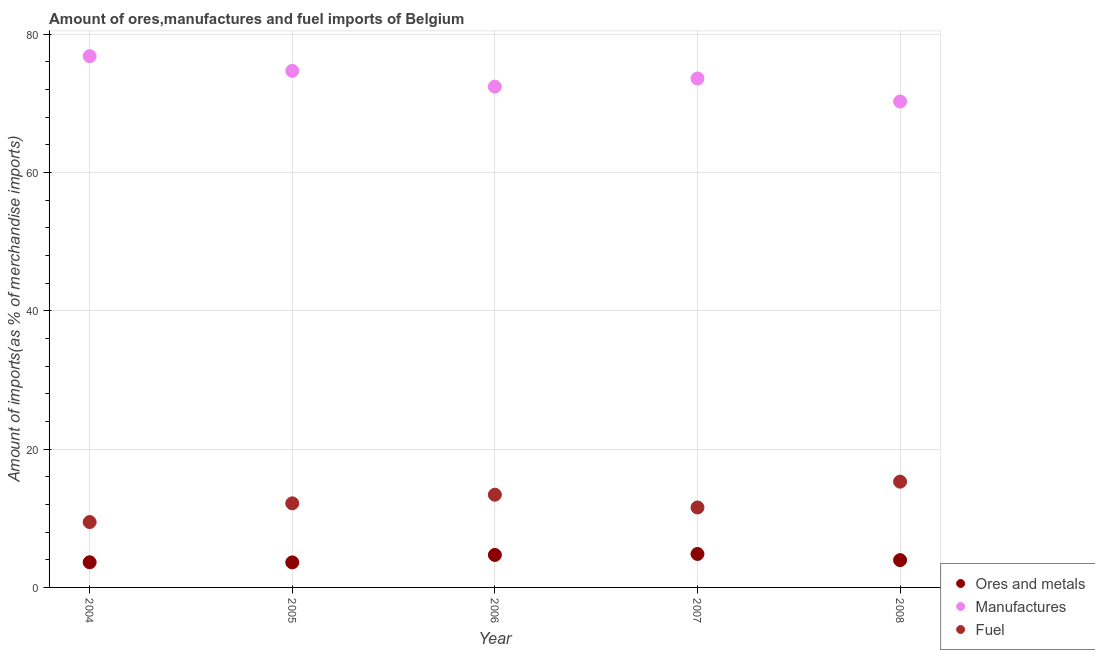How many different coloured dotlines are there?
Your response must be concise. 3. Is the number of dotlines equal to the number of legend labels?
Ensure brevity in your answer.  Yes. What is the percentage of fuel imports in 2004?
Keep it short and to the point. 9.45. Across all years, what is the maximum percentage of manufactures imports?
Give a very brief answer. 76.8. Across all years, what is the minimum percentage of ores and metals imports?
Keep it short and to the point. 3.62. In which year was the percentage of manufactures imports maximum?
Make the answer very short. 2004. In which year was the percentage of fuel imports minimum?
Give a very brief answer. 2004. What is the total percentage of ores and metals imports in the graph?
Offer a very short reply. 20.73. What is the difference between the percentage of manufactures imports in 2005 and that in 2008?
Give a very brief answer. 4.43. What is the difference between the percentage of ores and metals imports in 2007 and the percentage of manufactures imports in 2008?
Keep it short and to the point. -65.41. What is the average percentage of ores and metals imports per year?
Provide a short and direct response. 4.15. In the year 2004, what is the difference between the percentage of ores and metals imports and percentage of fuel imports?
Provide a short and direct response. -5.81. What is the ratio of the percentage of fuel imports in 2005 to that in 2006?
Keep it short and to the point. 0.91. Is the percentage of ores and metals imports in 2004 less than that in 2008?
Give a very brief answer. Yes. What is the difference between the highest and the second highest percentage of fuel imports?
Offer a terse response. 1.88. What is the difference between the highest and the lowest percentage of fuel imports?
Offer a terse response. 5.84. In how many years, is the percentage of ores and metals imports greater than the average percentage of ores and metals imports taken over all years?
Give a very brief answer. 2. Is the sum of the percentage of fuel imports in 2004 and 2006 greater than the maximum percentage of manufactures imports across all years?
Provide a succinct answer. No. Is it the case that in every year, the sum of the percentage of ores and metals imports and percentage of manufactures imports is greater than the percentage of fuel imports?
Provide a short and direct response. Yes. How many dotlines are there?
Your answer should be compact. 3. How many years are there in the graph?
Give a very brief answer. 5. Are the values on the major ticks of Y-axis written in scientific E-notation?
Offer a terse response. No. Does the graph contain grids?
Your response must be concise. Yes. Where does the legend appear in the graph?
Ensure brevity in your answer.  Bottom right. How many legend labels are there?
Offer a terse response. 3. What is the title of the graph?
Offer a very short reply. Amount of ores,manufactures and fuel imports of Belgium. Does "Slovak Republic" appear as one of the legend labels in the graph?
Provide a succinct answer. No. What is the label or title of the X-axis?
Your response must be concise. Year. What is the label or title of the Y-axis?
Your answer should be compact. Amount of imports(as % of merchandise imports). What is the Amount of imports(as % of merchandise imports) in Ores and metals in 2004?
Offer a terse response. 3.64. What is the Amount of imports(as % of merchandise imports) of Manufactures in 2004?
Your response must be concise. 76.8. What is the Amount of imports(as % of merchandise imports) in Fuel in 2004?
Keep it short and to the point. 9.45. What is the Amount of imports(as % of merchandise imports) of Ores and metals in 2005?
Offer a very short reply. 3.62. What is the Amount of imports(as % of merchandise imports) of Manufactures in 2005?
Your response must be concise. 74.68. What is the Amount of imports(as % of merchandise imports) of Fuel in 2005?
Make the answer very short. 12.16. What is the Amount of imports(as % of merchandise imports) of Ores and metals in 2006?
Offer a terse response. 4.7. What is the Amount of imports(as % of merchandise imports) in Manufactures in 2006?
Provide a succinct answer. 72.39. What is the Amount of imports(as % of merchandise imports) of Fuel in 2006?
Ensure brevity in your answer.  13.4. What is the Amount of imports(as % of merchandise imports) in Ores and metals in 2007?
Keep it short and to the point. 4.84. What is the Amount of imports(as % of merchandise imports) in Manufactures in 2007?
Your answer should be very brief. 73.57. What is the Amount of imports(as % of merchandise imports) in Fuel in 2007?
Offer a very short reply. 11.56. What is the Amount of imports(as % of merchandise imports) of Ores and metals in 2008?
Keep it short and to the point. 3.95. What is the Amount of imports(as % of merchandise imports) of Manufactures in 2008?
Your answer should be very brief. 70.24. What is the Amount of imports(as % of merchandise imports) of Fuel in 2008?
Give a very brief answer. 15.29. Across all years, what is the maximum Amount of imports(as % of merchandise imports) of Ores and metals?
Your answer should be very brief. 4.84. Across all years, what is the maximum Amount of imports(as % of merchandise imports) in Manufactures?
Provide a succinct answer. 76.8. Across all years, what is the maximum Amount of imports(as % of merchandise imports) of Fuel?
Make the answer very short. 15.29. Across all years, what is the minimum Amount of imports(as % of merchandise imports) of Ores and metals?
Your answer should be compact. 3.62. Across all years, what is the minimum Amount of imports(as % of merchandise imports) of Manufactures?
Keep it short and to the point. 70.24. Across all years, what is the minimum Amount of imports(as % of merchandise imports) of Fuel?
Your response must be concise. 9.45. What is the total Amount of imports(as % of merchandise imports) in Ores and metals in the graph?
Your response must be concise. 20.73. What is the total Amount of imports(as % of merchandise imports) of Manufactures in the graph?
Your answer should be compact. 367.68. What is the total Amount of imports(as % of merchandise imports) in Fuel in the graph?
Give a very brief answer. 61.85. What is the difference between the Amount of imports(as % of merchandise imports) in Ores and metals in 2004 and that in 2005?
Keep it short and to the point. 0.02. What is the difference between the Amount of imports(as % of merchandise imports) of Manufactures in 2004 and that in 2005?
Your response must be concise. 2.13. What is the difference between the Amount of imports(as % of merchandise imports) of Fuel in 2004 and that in 2005?
Your answer should be compact. -2.71. What is the difference between the Amount of imports(as % of merchandise imports) in Ores and metals in 2004 and that in 2006?
Provide a succinct answer. -1.06. What is the difference between the Amount of imports(as % of merchandise imports) of Manufactures in 2004 and that in 2006?
Your answer should be very brief. 4.41. What is the difference between the Amount of imports(as % of merchandise imports) of Fuel in 2004 and that in 2006?
Give a very brief answer. -3.95. What is the difference between the Amount of imports(as % of merchandise imports) of Ores and metals in 2004 and that in 2007?
Your response must be concise. -1.2. What is the difference between the Amount of imports(as % of merchandise imports) in Manufactures in 2004 and that in 2007?
Your answer should be compact. 3.23. What is the difference between the Amount of imports(as % of merchandise imports) of Fuel in 2004 and that in 2007?
Provide a short and direct response. -2.1. What is the difference between the Amount of imports(as % of merchandise imports) in Ores and metals in 2004 and that in 2008?
Your answer should be very brief. -0.31. What is the difference between the Amount of imports(as % of merchandise imports) of Manufactures in 2004 and that in 2008?
Give a very brief answer. 6.56. What is the difference between the Amount of imports(as % of merchandise imports) in Fuel in 2004 and that in 2008?
Provide a succinct answer. -5.84. What is the difference between the Amount of imports(as % of merchandise imports) in Ores and metals in 2005 and that in 2006?
Your response must be concise. -1.08. What is the difference between the Amount of imports(as % of merchandise imports) in Manufactures in 2005 and that in 2006?
Provide a short and direct response. 2.28. What is the difference between the Amount of imports(as % of merchandise imports) of Fuel in 2005 and that in 2006?
Make the answer very short. -1.25. What is the difference between the Amount of imports(as % of merchandise imports) of Ores and metals in 2005 and that in 2007?
Offer a very short reply. -1.22. What is the difference between the Amount of imports(as % of merchandise imports) of Manufactures in 2005 and that in 2007?
Offer a terse response. 1.1. What is the difference between the Amount of imports(as % of merchandise imports) of Fuel in 2005 and that in 2007?
Your response must be concise. 0.6. What is the difference between the Amount of imports(as % of merchandise imports) in Ores and metals in 2005 and that in 2008?
Provide a short and direct response. -0.33. What is the difference between the Amount of imports(as % of merchandise imports) in Manufactures in 2005 and that in 2008?
Provide a short and direct response. 4.43. What is the difference between the Amount of imports(as % of merchandise imports) in Fuel in 2005 and that in 2008?
Keep it short and to the point. -3.13. What is the difference between the Amount of imports(as % of merchandise imports) of Ores and metals in 2006 and that in 2007?
Your answer should be compact. -0.14. What is the difference between the Amount of imports(as % of merchandise imports) in Manufactures in 2006 and that in 2007?
Ensure brevity in your answer.  -1.18. What is the difference between the Amount of imports(as % of merchandise imports) in Fuel in 2006 and that in 2007?
Ensure brevity in your answer.  1.85. What is the difference between the Amount of imports(as % of merchandise imports) in Ores and metals in 2006 and that in 2008?
Keep it short and to the point. 0.75. What is the difference between the Amount of imports(as % of merchandise imports) in Manufactures in 2006 and that in 2008?
Give a very brief answer. 2.15. What is the difference between the Amount of imports(as % of merchandise imports) of Fuel in 2006 and that in 2008?
Keep it short and to the point. -1.88. What is the difference between the Amount of imports(as % of merchandise imports) of Ores and metals in 2007 and that in 2008?
Your response must be concise. 0.89. What is the difference between the Amount of imports(as % of merchandise imports) in Manufactures in 2007 and that in 2008?
Give a very brief answer. 3.33. What is the difference between the Amount of imports(as % of merchandise imports) in Fuel in 2007 and that in 2008?
Offer a very short reply. -3.73. What is the difference between the Amount of imports(as % of merchandise imports) in Ores and metals in 2004 and the Amount of imports(as % of merchandise imports) in Manufactures in 2005?
Keep it short and to the point. -71.04. What is the difference between the Amount of imports(as % of merchandise imports) in Ores and metals in 2004 and the Amount of imports(as % of merchandise imports) in Fuel in 2005?
Your answer should be compact. -8.52. What is the difference between the Amount of imports(as % of merchandise imports) in Manufactures in 2004 and the Amount of imports(as % of merchandise imports) in Fuel in 2005?
Provide a short and direct response. 64.64. What is the difference between the Amount of imports(as % of merchandise imports) of Ores and metals in 2004 and the Amount of imports(as % of merchandise imports) of Manufactures in 2006?
Give a very brief answer. -68.75. What is the difference between the Amount of imports(as % of merchandise imports) of Ores and metals in 2004 and the Amount of imports(as % of merchandise imports) of Fuel in 2006?
Your answer should be very brief. -9.77. What is the difference between the Amount of imports(as % of merchandise imports) in Manufactures in 2004 and the Amount of imports(as % of merchandise imports) in Fuel in 2006?
Offer a terse response. 63.4. What is the difference between the Amount of imports(as % of merchandise imports) of Ores and metals in 2004 and the Amount of imports(as % of merchandise imports) of Manufactures in 2007?
Give a very brief answer. -69.93. What is the difference between the Amount of imports(as % of merchandise imports) of Ores and metals in 2004 and the Amount of imports(as % of merchandise imports) of Fuel in 2007?
Offer a very short reply. -7.92. What is the difference between the Amount of imports(as % of merchandise imports) in Manufactures in 2004 and the Amount of imports(as % of merchandise imports) in Fuel in 2007?
Ensure brevity in your answer.  65.25. What is the difference between the Amount of imports(as % of merchandise imports) of Ores and metals in 2004 and the Amount of imports(as % of merchandise imports) of Manufactures in 2008?
Your answer should be compact. -66.61. What is the difference between the Amount of imports(as % of merchandise imports) in Ores and metals in 2004 and the Amount of imports(as % of merchandise imports) in Fuel in 2008?
Provide a succinct answer. -11.65. What is the difference between the Amount of imports(as % of merchandise imports) in Manufactures in 2004 and the Amount of imports(as % of merchandise imports) in Fuel in 2008?
Make the answer very short. 61.51. What is the difference between the Amount of imports(as % of merchandise imports) in Ores and metals in 2005 and the Amount of imports(as % of merchandise imports) in Manufactures in 2006?
Keep it short and to the point. -68.77. What is the difference between the Amount of imports(as % of merchandise imports) in Ores and metals in 2005 and the Amount of imports(as % of merchandise imports) in Fuel in 2006?
Ensure brevity in your answer.  -9.78. What is the difference between the Amount of imports(as % of merchandise imports) in Manufactures in 2005 and the Amount of imports(as % of merchandise imports) in Fuel in 2006?
Keep it short and to the point. 61.27. What is the difference between the Amount of imports(as % of merchandise imports) in Ores and metals in 2005 and the Amount of imports(as % of merchandise imports) in Manufactures in 2007?
Ensure brevity in your answer.  -69.95. What is the difference between the Amount of imports(as % of merchandise imports) of Ores and metals in 2005 and the Amount of imports(as % of merchandise imports) of Fuel in 2007?
Your response must be concise. -7.94. What is the difference between the Amount of imports(as % of merchandise imports) in Manufactures in 2005 and the Amount of imports(as % of merchandise imports) in Fuel in 2007?
Provide a short and direct response. 63.12. What is the difference between the Amount of imports(as % of merchandise imports) of Ores and metals in 2005 and the Amount of imports(as % of merchandise imports) of Manufactures in 2008?
Your answer should be compact. -66.62. What is the difference between the Amount of imports(as % of merchandise imports) of Ores and metals in 2005 and the Amount of imports(as % of merchandise imports) of Fuel in 2008?
Ensure brevity in your answer.  -11.67. What is the difference between the Amount of imports(as % of merchandise imports) of Manufactures in 2005 and the Amount of imports(as % of merchandise imports) of Fuel in 2008?
Give a very brief answer. 59.39. What is the difference between the Amount of imports(as % of merchandise imports) of Ores and metals in 2006 and the Amount of imports(as % of merchandise imports) of Manufactures in 2007?
Give a very brief answer. -68.88. What is the difference between the Amount of imports(as % of merchandise imports) of Ores and metals in 2006 and the Amount of imports(as % of merchandise imports) of Fuel in 2007?
Keep it short and to the point. -6.86. What is the difference between the Amount of imports(as % of merchandise imports) in Manufactures in 2006 and the Amount of imports(as % of merchandise imports) in Fuel in 2007?
Provide a short and direct response. 60.84. What is the difference between the Amount of imports(as % of merchandise imports) in Ores and metals in 2006 and the Amount of imports(as % of merchandise imports) in Manufactures in 2008?
Offer a very short reply. -65.55. What is the difference between the Amount of imports(as % of merchandise imports) in Ores and metals in 2006 and the Amount of imports(as % of merchandise imports) in Fuel in 2008?
Offer a terse response. -10.59. What is the difference between the Amount of imports(as % of merchandise imports) of Manufactures in 2006 and the Amount of imports(as % of merchandise imports) of Fuel in 2008?
Make the answer very short. 57.1. What is the difference between the Amount of imports(as % of merchandise imports) in Ores and metals in 2007 and the Amount of imports(as % of merchandise imports) in Manufactures in 2008?
Your response must be concise. -65.41. What is the difference between the Amount of imports(as % of merchandise imports) of Ores and metals in 2007 and the Amount of imports(as % of merchandise imports) of Fuel in 2008?
Ensure brevity in your answer.  -10.45. What is the difference between the Amount of imports(as % of merchandise imports) of Manufactures in 2007 and the Amount of imports(as % of merchandise imports) of Fuel in 2008?
Provide a succinct answer. 58.28. What is the average Amount of imports(as % of merchandise imports) of Ores and metals per year?
Offer a terse response. 4.15. What is the average Amount of imports(as % of merchandise imports) of Manufactures per year?
Give a very brief answer. 73.54. What is the average Amount of imports(as % of merchandise imports) in Fuel per year?
Provide a short and direct response. 12.37. In the year 2004, what is the difference between the Amount of imports(as % of merchandise imports) in Ores and metals and Amount of imports(as % of merchandise imports) in Manufactures?
Offer a very short reply. -73.16. In the year 2004, what is the difference between the Amount of imports(as % of merchandise imports) of Ores and metals and Amount of imports(as % of merchandise imports) of Fuel?
Keep it short and to the point. -5.81. In the year 2004, what is the difference between the Amount of imports(as % of merchandise imports) of Manufactures and Amount of imports(as % of merchandise imports) of Fuel?
Ensure brevity in your answer.  67.35. In the year 2005, what is the difference between the Amount of imports(as % of merchandise imports) in Ores and metals and Amount of imports(as % of merchandise imports) in Manufactures?
Make the answer very short. -71.06. In the year 2005, what is the difference between the Amount of imports(as % of merchandise imports) in Ores and metals and Amount of imports(as % of merchandise imports) in Fuel?
Your response must be concise. -8.54. In the year 2005, what is the difference between the Amount of imports(as % of merchandise imports) in Manufactures and Amount of imports(as % of merchandise imports) in Fuel?
Keep it short and to the point. 62.52. In the year 2006, what is the difference between the Amount of imports(as % of merchandise imports) of Ores and metals and Amount of imports(as % of merchandise imports) of Manufactures?
Give a very brief answer. -67.7. In the year 2006, what is the difference between the Amount of imports(as % of merchandise imports) in Ores and metals and Amount of imports(as % of merchandise imports) in Fuel?
Your answer should be very brief. -8.71. In the year 2006, what is the difference between the Amount of imports(as % of merchandise imports) of Manufactures and Amount of imports(as % of merchandise imports) of Fuel?
Keep it short and to the point. 58.99. In the year 2007, what is the difference between the Amount of imports(as % of merchandise imports) in Ores and metals and Amount of imports(as % of merchandise imports) in Manufactures?
Offer a terse response. -68.73. In the year 2007, what is the difference between the Amount of imports(as % of merchandise imports) in Ores and metals and Amount of imports(as % of merchandise imports) in Fuel?
Give a very brief answer. -6.72. In the year 2007, what is the difference between the Amount of imports(as % of merchandise imports) in Manufactures and Amount of imports(as % of merchandise imports) in Fuel?
Your answer should be very brief. 62.02. In the year 2008, what is the difference between the Amount of imports(as % of merchandise imports) of Ores and metals and Amount of imports(as % of merchandise imports) of Manufactures?
Offer a very short reply. -66.3. In the year 2008, what is the difference between the Amount of imports(as % of merchandise imports) in Ores and metals and Amount of imports(as % of merchandise imports) in Fuel?
Keep it short and to the point. -11.34. In the year 2008, what is the difference between the Amount of imports(as % of merchandise imports) in Manufactures and Amount of imports(as % of merchandise imports) in Fuel?
Offer a very short reply. 54.96. What is the ratio of the Amount of imports(as % of merchandise imports) of Ores and metals in 2004 to that in 2005?
Provide a succinct answer. 1. What is the ratio of the Amount of imports(as % of merchandise imports) in Manufactures in 2004 to that in 2005?
Give a very brief answer. 1.03. What is the ratio of the Amount of imports(as % of merchandise imports) of Fuel in 2004 to that in 2005?
Give a very brief answer. 0.78. What is the ratio of the Amount of imports(as % of merchandise imports) of Ores and metals in 2004 to that in 2006?
Provide a succinct answer. 0.77. What is the ratio of the Amount of imports(as % of merchandise imports) of Manufactures in 2004 to that in 2006?
Offer a very short reply. 1.06. What is the ratio of the Amount of imports(as % of merchandise imports) of Fuel in 2004 to that in 2006?
Give a very brief answer. 0.71. What is the ratio of the Amount of imports(as % of merchandise imports) in Ores and metals in 2004 to that in 2007?
Your answer should be compact. 0.75. What is the ratio of the Amount of imports(as % of merchandise imports) of Manufactures in 2004 to that in 2007?
Offer a very short reply. 1.04. What is the ratio of the Amount of imports(as % of merchandise imports) of Fuel in 2004 to that in 2007?
Your response must be concise. 0.82. What is the ratio of the Amount of imports(as % of merchandise imports) in Ores and metals in 2004 to that in 2008?
Provide a succinct answer. 0.92. What is the ratio of the Amount of imports(as % of merchandise imports) in Manufactures in 2004 to that in 2008?
Keep it short and to the point. 1.09. What is the ratio of the Amount of imports(as % of merchandise imports) in Fuel in 2004 to that in 2008?
Your answer should be very brief. 0.62. What is the ratio of the Amount of imports(as % of merchandise imports) in Ores and metals in 2005 to that in 2006?
Your answer should be compact. 0.77. What is the ratio of the Amount of imports(as % of merchandise imports) in Manufactures in 2005 to that in 2006?
Make the answer very short. 1.03. What is the ratio of the Amount of imports(as % of merchandise imports) in Fuel in 2005 to that in 2006?
Ensure brevity in your answer.  0.91. What is the ratio of the Amount of imports(as % of merchandise imports) of Ores and metals in 2005 to that in 2007?
Keep it short and to the point. 0.75. What is the ratio of the Amount of imports(as % of merchandise imports) in Fuel in 2005 to that in 2007?
Make the answer very short. 1.05. What is the ratio of the Amount of imports(as % of merchandise imports) in Ores and metals in 2005 to that in 2008?
Keep it short and to the point. 0.92. What is the ratio of the Amount of imports(as % of merchandise imports) in Manufactures in 2005 to that in 2008?
Your response must be concise. 1.06. What is the ratio of the Amount of imports(as % of merchandise imports) of Fuel in 2005 to that in 2008?
Keep it short and to the point. 0.8. What is the ratio of the Amount of imports(as % of merchandise imports) in Ores and metals in 2006 to that in 2007?
Your answer should be very brief. 0.97. What is the ratio of the Amount of imports(as % of merchandise imports) of Manufactures in 2006 to that in 2007?
Offer a very short reply. 0.98. What is the ratio of the Amount of imports(as % of merchandise imports) of Fuel in 2006 to that in 2007?
Provide a short and direct response. 1.16. What is the ratio of the Amount of imports(as % of merchandise imports) of Ores and metals in 2006 to that in 2008?
Your answer should be compact. 1.19. What is the ratio of the Amount of imports(as % of merchandise imports) in Manufactures in 2006 to that in 2008?
Offer a terse response. 1.03. What is the ratio of the Amount of imports(as % of merchandise imports) of Fuel in 2006 to that in 2008?
Your answer should be compact. 0.88. What is the ratio of the Amount of imports(as % of merchandise imports) in Ores and metals in 2007 to that in 2008?
Your response must be concise. 1.23. What is the ratio of the Amount of imports(as % of merchandise imports) in Manufactures in 2007 to that in 2008?
Offer a terse response. 1.05. What is the ratio of the Amount of imports(as % of merchandise imports) of Fuel in 2007 to that in 2008?
Offer a terse response. 0.76. What is the difference between the highest and the second highest Amount of imports(as % of merchandise imports) in Ores and metals?
Keep it short and to the point. 0.14. What is the difference between the highest and the second highest Amount of imports(as % of merchandise imports) of Manufactures?
Give a very brief answer. 2.13. What is the difference between the highest and the second highest Amount of imports(as % of merchandise imports) of Fuel?
Offer a terse response. 1.88. What is the difference between the highest and the lowest Amount of imports(as % of merchandise imports) of Ores and metals?
Your response must be concise. 1.22. What is the difference between the highest and the lowest Amount of imports(as % of merchandise imports) in Manufactures?
Offer a terse response. 6.56. What is the difference between the highest and the lowest Amount of imports(as % of merchandise imports) of Fuel?
Your response must be concise. 5.84. 